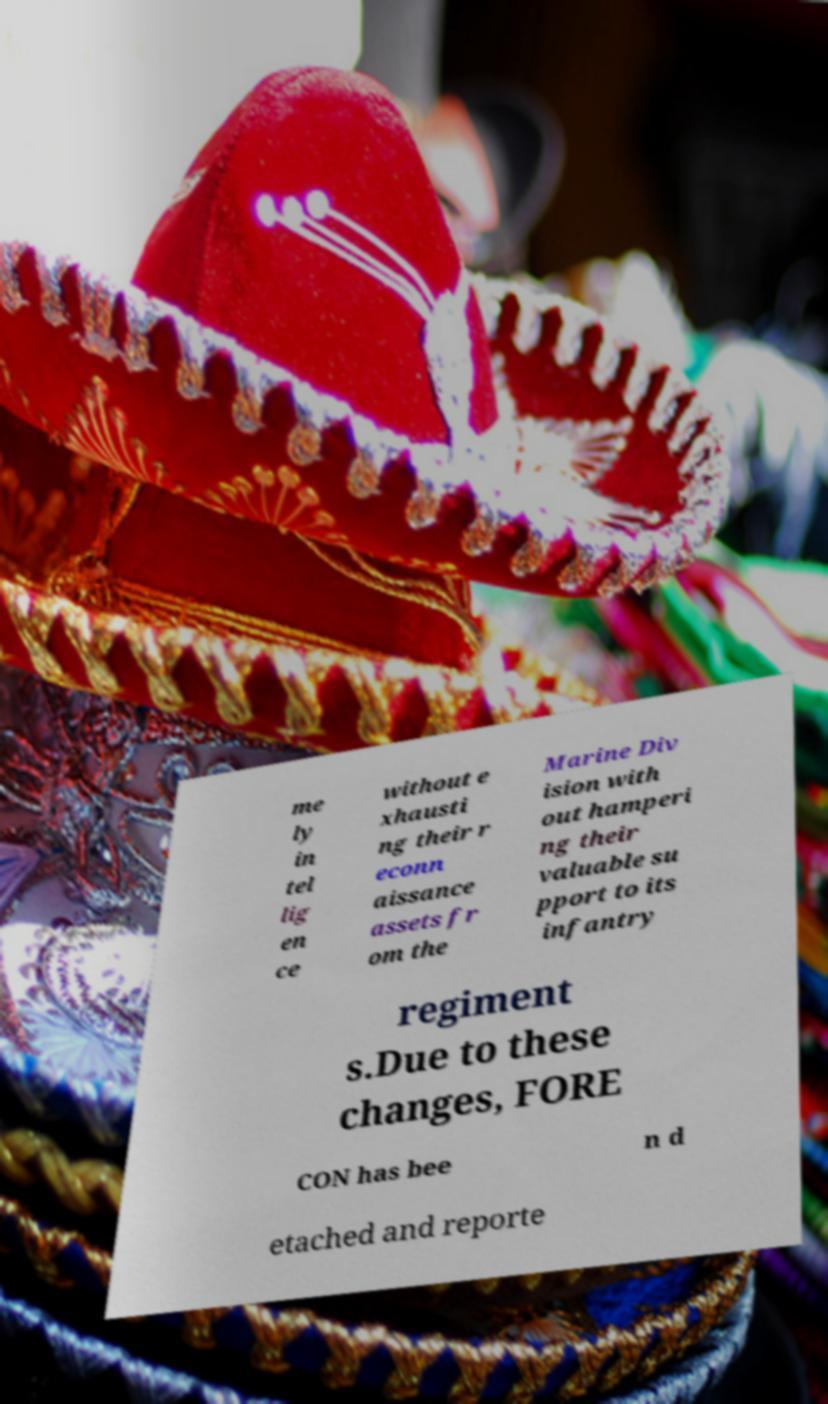Please identify and transcribe the text found in this image. me ly in tel lig en ce without e xhausti ng their r econn aissance assets fr om the Marine Div ision with out hamperi ng their valuable su pport to its infantry regiment s.Due to these changes, FORE CON has bee n d etached and reporte 